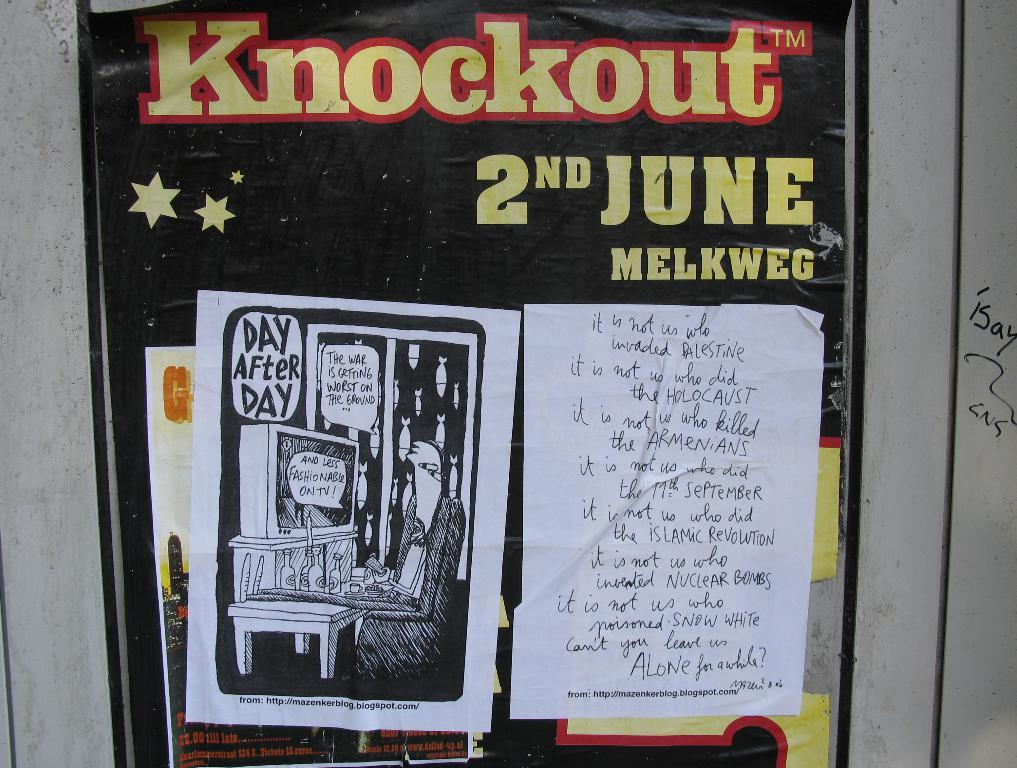<image>
Provide a brief description of the given image. Posted on a wall a political cartoon and message about war are asking to be left a lone. 